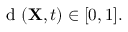Convert formula to latex. <formula><loc_0><loc_0><loc_500><loc_500>d ( { X } , t ) \in [ 0 , 1 ] .</formula> 